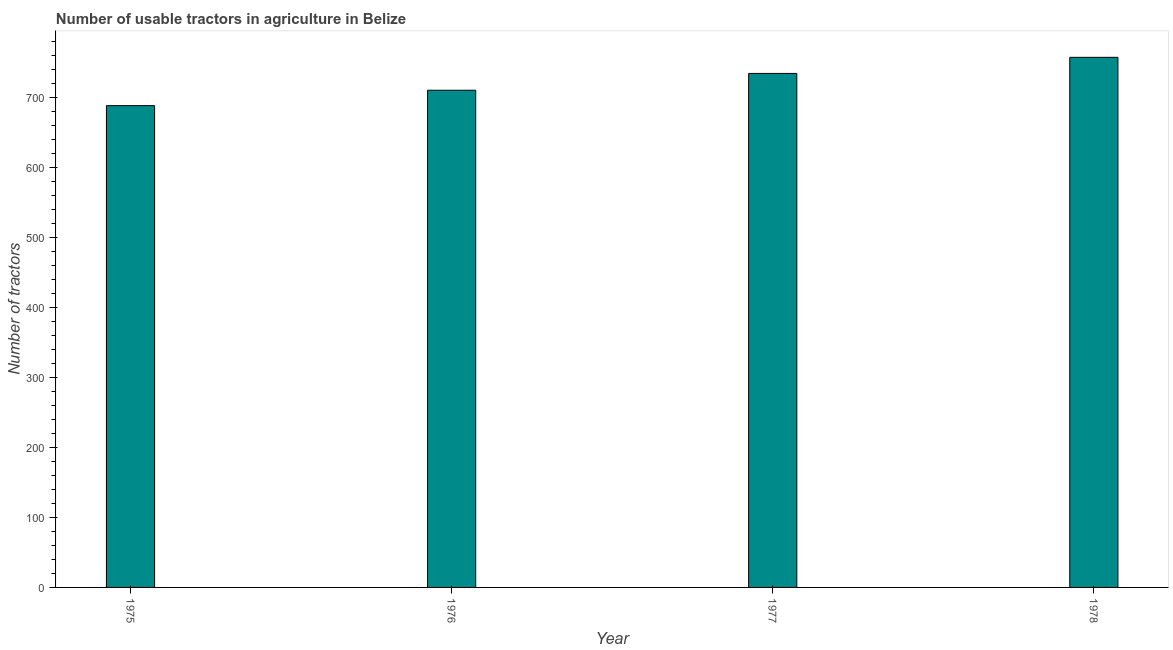Does the graph contain grids?
Provide a short and direct response. No. What is the title of the graph?
Make the answer very short. Number of usable tractors in agriculture in Belize. What is the label or title of the Y-axis?
Make the answer very short. Number of tractors. What is the number of tractors in 1978?
Offer a very short reply. 757. Across all years, what is the maximum number of tractors?
Offer a terse response. 757. Across all years, what is the minimum number of tractors?
Give a very brief answer. 688. In which year was the number of tractors maximum?
Ensure brevity in your answer.  1978. In which year was the number of tractors minimum?
Your answer should be very brief. 1975. What is the sum of the number of tractors?
Keep it short and to the point. 2889. What is the difference between the number of tractors in 1975 and 1978?
Offer a very short reply. -69. What is the average number of tractors per year?
Offer a terse response. 722. What is the median number of tractors?
Your response must be concise. 722. In how many years, is the number of tractors greater than 200 ?
Your answer should be very brief. 4. Do a majority of the years between 1977 and 1976 (inclusive) have number of tractors greater than 640 ?
Make the answer very short. No. What is the ratio of the number of tractors in 1975 to that in 1977?
Your answer should be very brief. 0.94. What is the difference between the highest and the second highest number of tractors?
Offer a terse response. 23. What is the difference between the highest and the lowest number of tractors?
Offer a terse response. 69. How many years are there in the graph?
Offer a terse response. 4. What is the difference between two consecutive major ticks on the Y-axis?
Give a very brief answer. 100. What is the Number of tractors of 1975?
Offer a terse response. 688. What is the Number of tractors of 1976?
Your answer should be compact. 710. What is the Number of tractors of 1977?
Provide a short and direct response. 734. What is the Number of tractors of 1978?
Your response must be concise. 757. What is the difference between the Number of tractors in 1975 and 1976?
Offer a terse response. -22. What is the difference between the Number of tractors in 1975 and 1977?
Your answer should be very brief. -46. What is the difference between the Number of tractors in 1975 and 1978?
Give a very brief answer. -69. What is the difference between the Number of tractors in 1976 and 1978?
Make the answer very short. -47. What is the difference between the Number of tractors in 1977 and 1978?
Your answer should be very brief. -23. What is the ratio of the Number of tractors in 1975 to that in 1977?
Your answer should be very brief. 0.94. What is the ratio of the Number of tractors in 1975 to that in 1978?
Offer a terse response. 0.91. What is the ratio of the Number of tractors in 1976 to that in 1977?
Your answer should be compact. 0.97. What is the ratio of the Number of tractors in 1976 to that in 1978?
Provide a short and direct response. 0.94. 